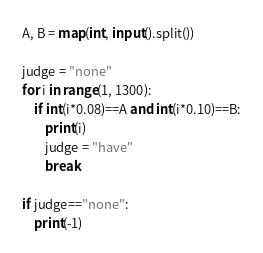Convert code to text. <code><loc_0><loc_0><loc_500><loc_500><_Python_>A, B = map(int, input().split())

judge = "none"
for i in range(1, 1300):
    if int(i*0.08)==A and int(i*0.10)==B:
        print(i)
        judge = "have"
        break

if judge=="none":
    print(-1)</code> 